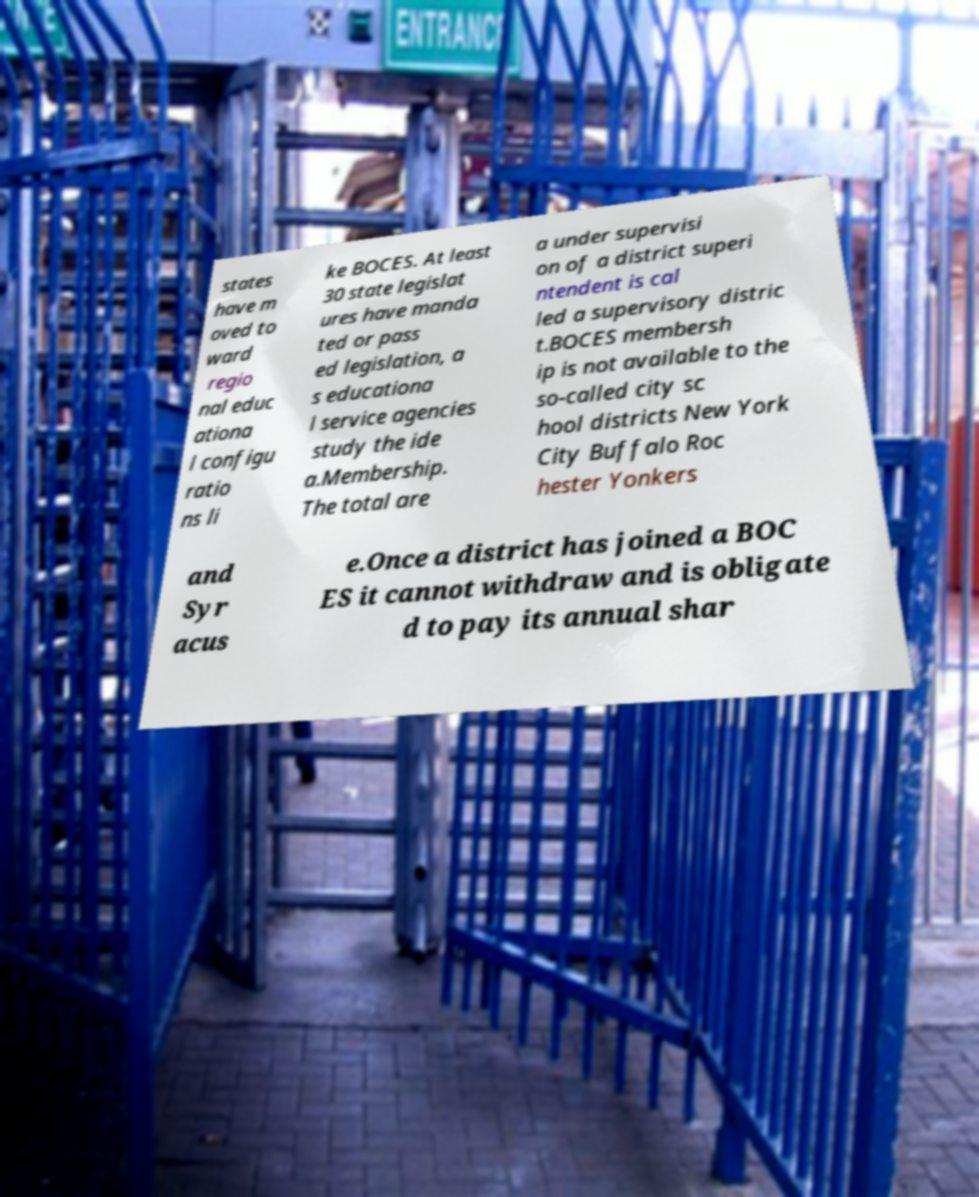Could you assist in decoding the text presented in this image and type it out clearly? states have m oved to ward regio nal educ ationa l configu ratio ns li ke BOCES. At least 30 state legislat ures have manda ted or pass ed legislation, a s educationa l service agencies study the ide a.Membership. The total are a under supervisi on of a district superi ntendent is cal led a supervisory distric t.BOCES membersh ip is not available to the so-called city sc hool districts New York City Buffalo Roc hester Yonkers and Syr acus e.Once a district has joined a BOC ES it cannot withdraw and is obligate d to pay its annual shar 